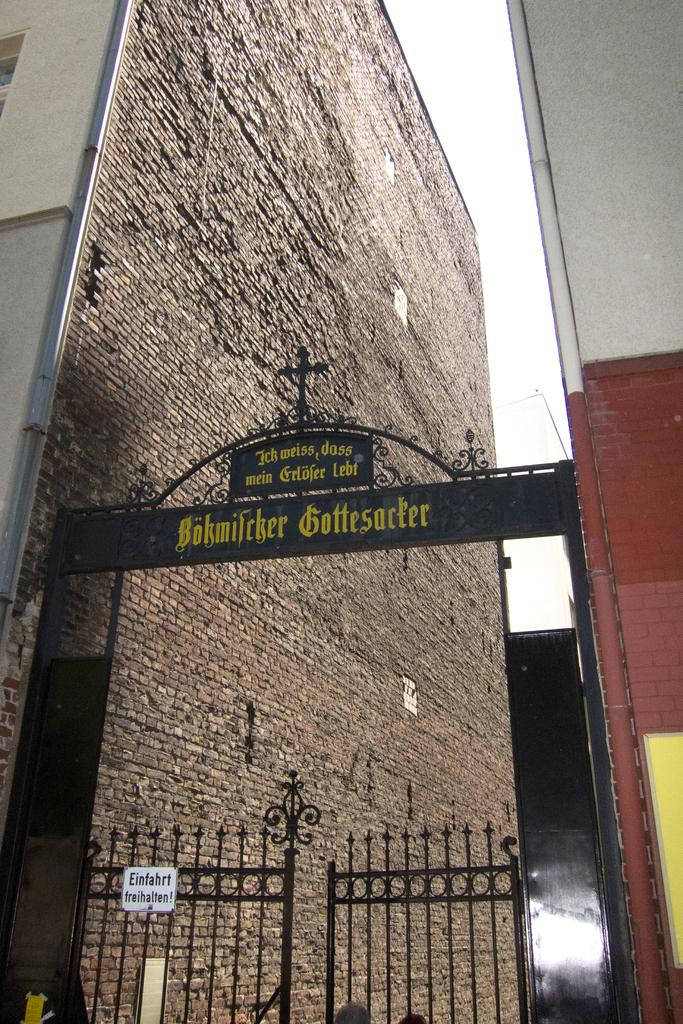What type of structure is visible in the picture? There is a building in the picture. What is the entrance to the building like? There is a gate in the picture. What is the condition of the sky in the picture? The sky is clear in the picture. What type of wine is being served at the science conference in the picture? There is no science conference or wine present in the image; it only features a building and a gate. 